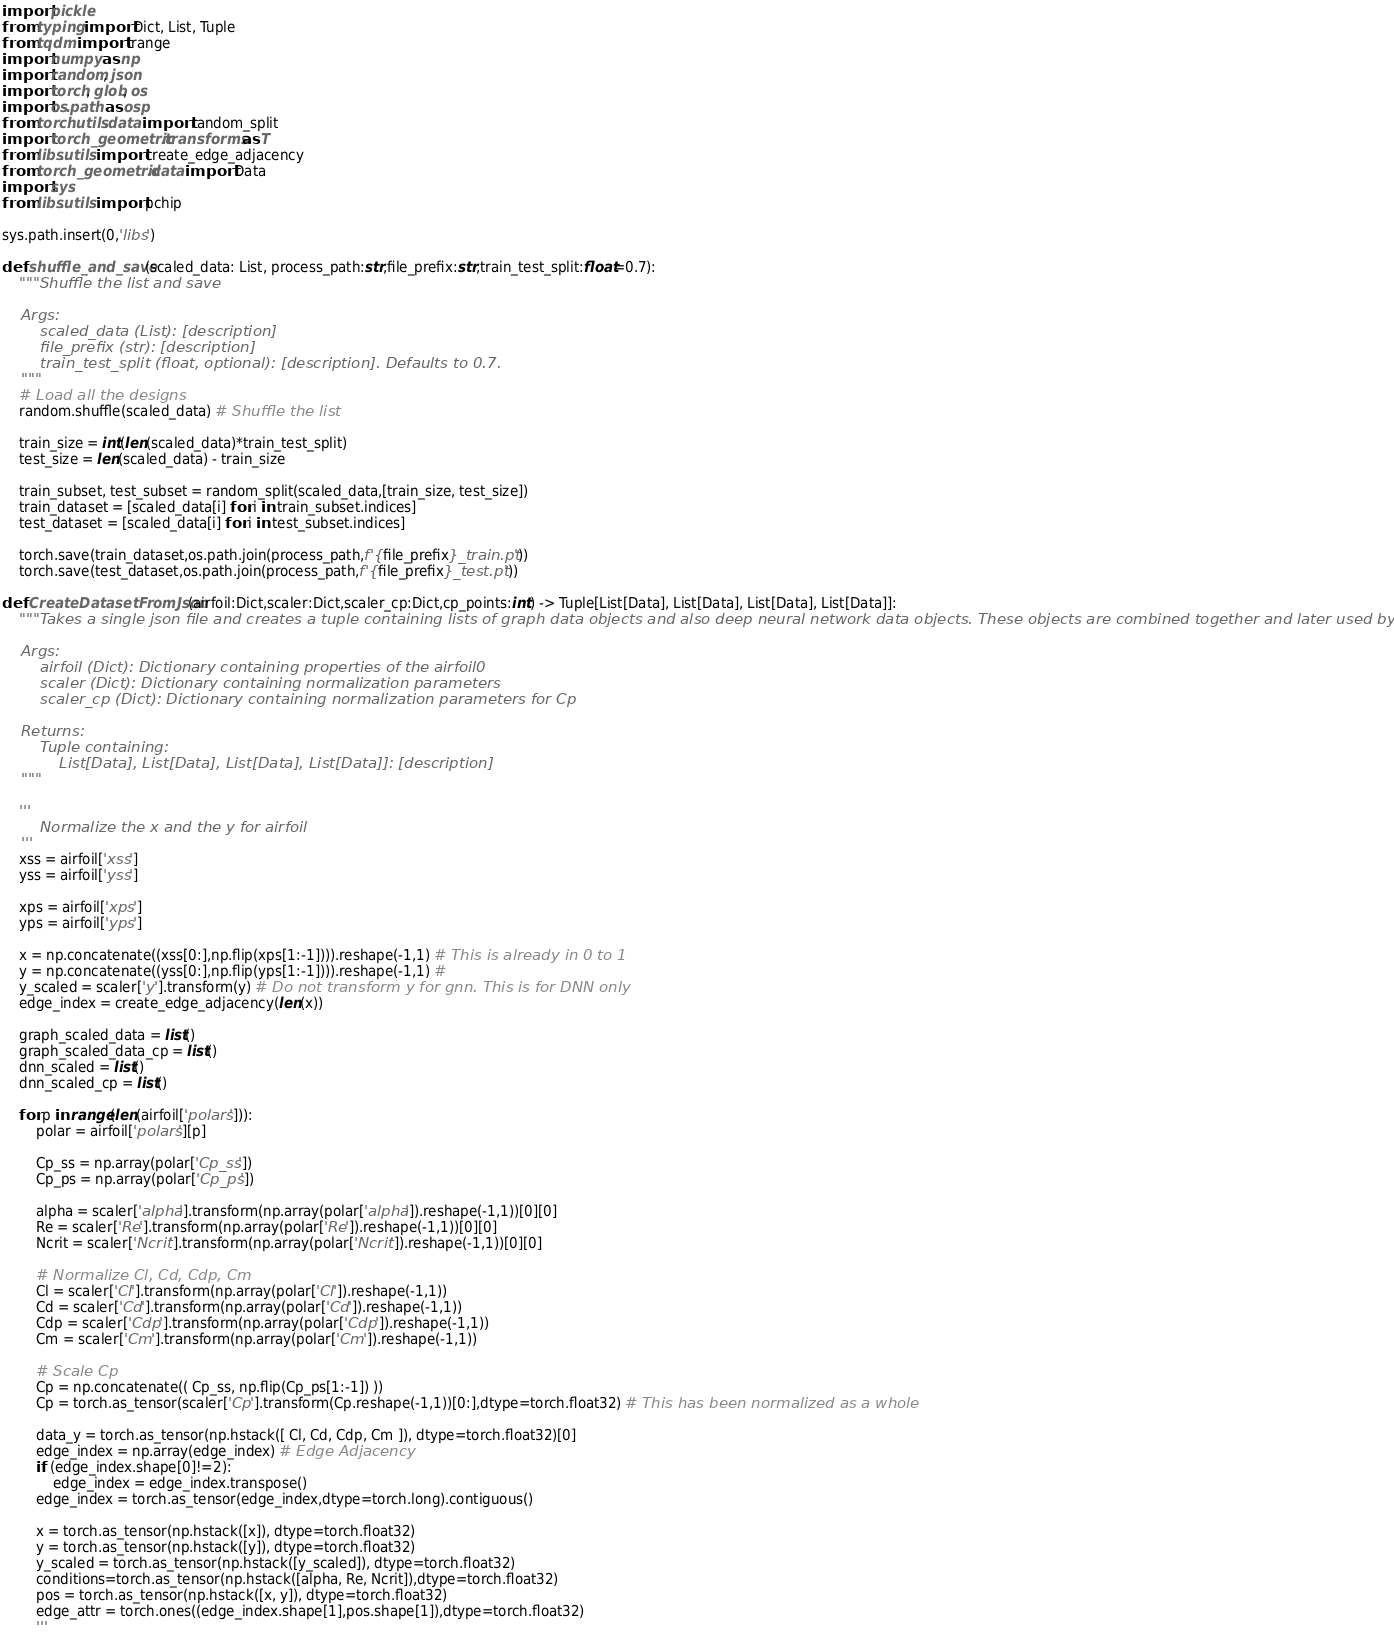Convert code to text. <code><loc_0><loc_0><loc_500><loc_500><_Python_>import pickle
from typing import Dict, List, Tuple
from tqdm import trange
import numpy as np
import random, json
import torch, glob, os
import os.path as osp
from torch.utils.data import random_split
import torch_geometric.transforms as T
from libs.utils import create_edge_adjacency
from torch_geometric.data import Data
import sys
from libs.utils import pchip

sys.path.insert(0,'libs')

def shuffle_and_save(scaled_data: List, process_path:str,file_prefix:str,train_test_split:float=0.7):
    """Shuffle the list and save

    Args:
        scaled_data (List): [description]
        file_prefix (str): [description]
        train_test_split (float, optional): [description]. Defaults to 0.7.
    """
    # Load all the designs 
    random.shuffle(scaled_data) # Shuffle the list
    
    train_size = int(len(scaled_data)*train_test_split)
    test_size = len(scaled_data) - train_size     

    train_subset, test_subset = random_split(scaled_data,[train_size, test_size])
    train_dataset = [scaled_data[i] for i in train_subset.indices] 
    test_dataset = [scaled_data[i] for i in test_subset.indices]     

    torch.save(train_dataset,os.path.join(process_path,f'{file_prefix}_train.pt'))
    torch.save(test_dataset,os.path.join(process_path,f'{file_prefix}_test.pt'))

def CreateDatasetFromJson(airfoil:Dict,scaler:Dict,scaler_cp:Dict,cp_points:int) -> Tuple[List[Data], List[Data], List[Data], List[Data]]:
    """Takes a single json file and creates a tuple containing lists of graph data objects and also deep neural network data objects. These objects are combined together and later used by pytorch dataloader 

    Args:
        airfoil (Dict): Dictionary containing properties of the airfoil0
        scaler (Dict): Dictionary containing normalization parameters 
        scaler_cp (Dict): Dictionary containing normalization parameters for Cp

    Returns:
        Tuple containing:
            List[Data], List[Data], List[Data], List[Data]]: [description]
    """
    
    '''
        Normalize the x and the y for airfoil 
    '''
    xss = airfoil['xss']        
    yss = airfoil['yss']

    xps = airfoil['xps']
    yps = airfoil['yps']
    
    x = np.concatenate((xss[0:],np.flip(xps[1:-1]))).reshape(-1,1) # This is already in 0 to 1
    y = np.concatenate((yss[0:],np.flip(yps[1:-1]))).reshape(-1,1) # 
    y_scaled = scaler['y'].transform(y) # Do not transform y for gnn. This is for DNN only 
    edge_index = create_edge_adjacency(len(x))

    graph_scaled_data = list()
    graph_scaled_data_cp = list() 
    dnn_scaled = list() 
    dnn_scaled_cp = list()

    for p in range(len(airfoil['polars'])):            
        polar = airfoil['polars'][p]

        Cp_ss = np.array(polar['Cp_ss'])
        Cp_ps = np.array(polar['Cp_ps'])
                    
        alpha = scaler['alpha'].transform(np.array(polar['alpha']).reshape(-1,1))[0][0]
        Re = scaler['Re'].transform(np.array(polar['Re']).reshape(-1,1))[0][0]
        Ncrit = scaler['Ncrit'].transform(np.array(polar['Ncrit']).reshape(-1,1))[0][0]

        # Normalize Cl, Cd, Cdp, Cm
        Cl = scaler['Cl'].transform(np.array(polar['Cl']).reshape(-1,1))
        Cd = scaler['Cd'].transform(np.array(polar['Cd']).reshape(-1,1))
        Cdp = scaler['Cdp'].transform(np.array(polar['Cdp']).reshape(-1,1))
        Cm = scaler['Cm'].transform(np.array(polar['Cm']).reshape(-1,1))

        # Scale Cp
        Cp = np.concatenate(( Cp_ss, np.flip(Cp_ps[1:-1]) ))
        Cp = torch.as_tensor(scaler['Cp'].transform(Cp.reshape(-1,1))[0:],dtype=torch.float32) # This has been normalized as a whole

        data_y = torch.as_tensor(np.hstack([ Cl, Cd, Cdp, Cm ]), dtype=torch.float32)[0]
        edge_index = np.array(edge_index) # Edge Adjacency 
        if (edge_index.shape[0]!=2):
            edge_index = edge_index.transpose()
        edge_index = torch.as_tensor(edge_index,dtype=torch.long).contiguous()

        x = torch.as_tensor(np.hstack([x]), dtype=torch.float32)
        y = torch.as_tensor(np.hstack([y]), dtype=torch.float32)
        y_scaled = torch.as_tensor(np.hstack([y_scaled]), dtype=torch.float32)
        conditions=torch.as_tensor(np.hstack([alpha, Re, Ncrit]),dtype=torch.float32)
        pos = torch.as_tensor(np.hstack([x, y]), dtype=torch.float32)
        edge_attr = torch.ones((edge_index.shape[1],pos.shape[1]),dtype=torch.float32)
        '''</code> 